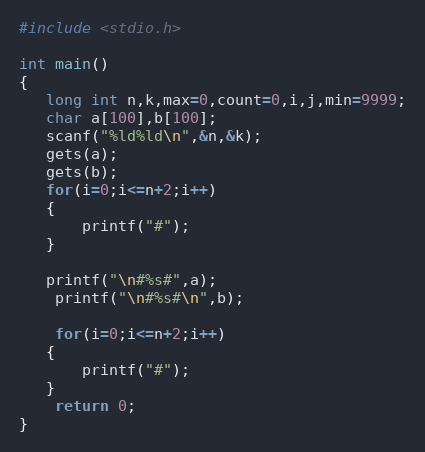<code> <loc_0><loc_0><loc_500><loc_500><_C_>#include <stdio.h>

int main()
{
   long int n,k,max=0,count=0,i,j,min=9999;
   char a[100],b[100];
   scanf("%ld%ld\n",&n,&k);
   gets(a);
   gets(b);
   for(i=0;i<=n+2;i++)
   {
       printf("#");
   }
   
   printf("\n#%s#",a);
    printf("\n#%s#\n",b);

    for(i=0;i<=n+2;i++)
   {
       printf("#");
   }
    return 0;
}
</code> 